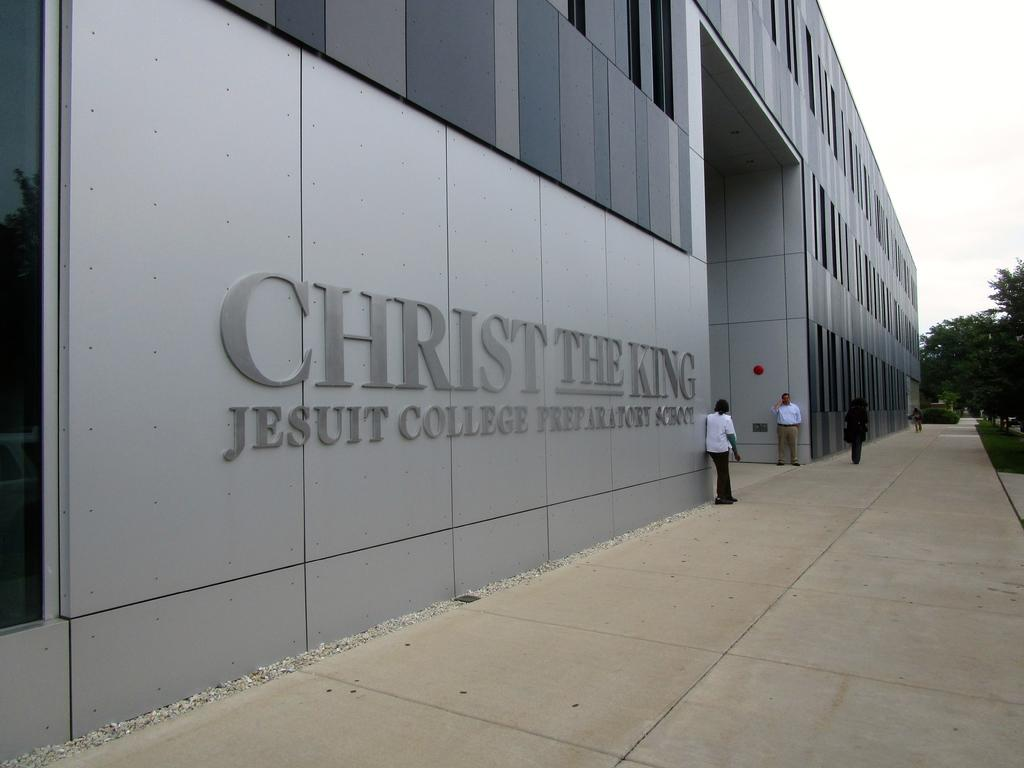What can be seen in the foreground of the image? There are people standing in front of a building. What type of vegetation is on the right side of the image? There are trees on the right side of the image. What is visible in the background of the image? The sky is visible in the background of the image. Are there any cushions visible in the image? There are no cushions present in the image. Can you see any food being prepared or consumed in the image? There is no food visible in the image. 